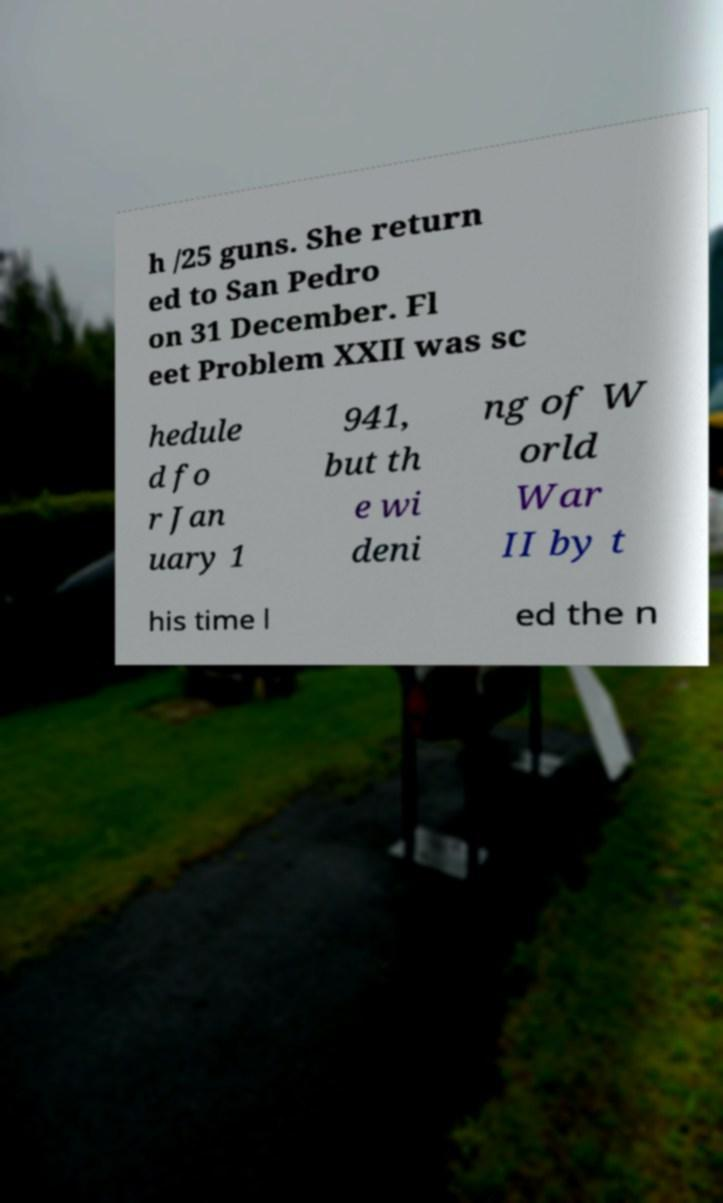There's text embedded in this image that I need extracted. Can you transcribe it verbatim? h /25 guns. She return ed to San Pedro on 31 December. Fl eet Problem XXII was sc hedule d fo r Jan uary 1 941, but th e wi deni ng of W orld War II by t his time l ed the n 